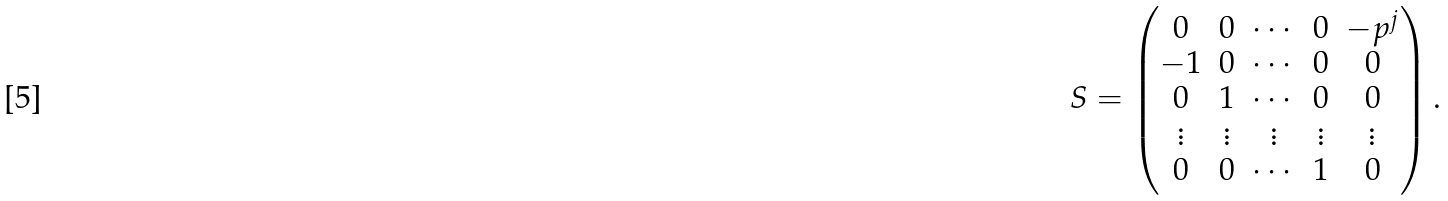Convert formula to latex. <formula><loc_0><loc_0><loc_500><loc_500>S = \begin{pmatrix} 0 & 0 & \cdots & 0 & - p ^ { j } \\ - 1 & 0 & \cdots & 0 & 0 \\ 0 & 1 & \cdots & 0 & 0 \\ \vdots & \vdots & \vdots & \vdots & \vdots \\ 0 & 0 & \cdots & 1 & 0 \end{pmatrix} .</formula> 